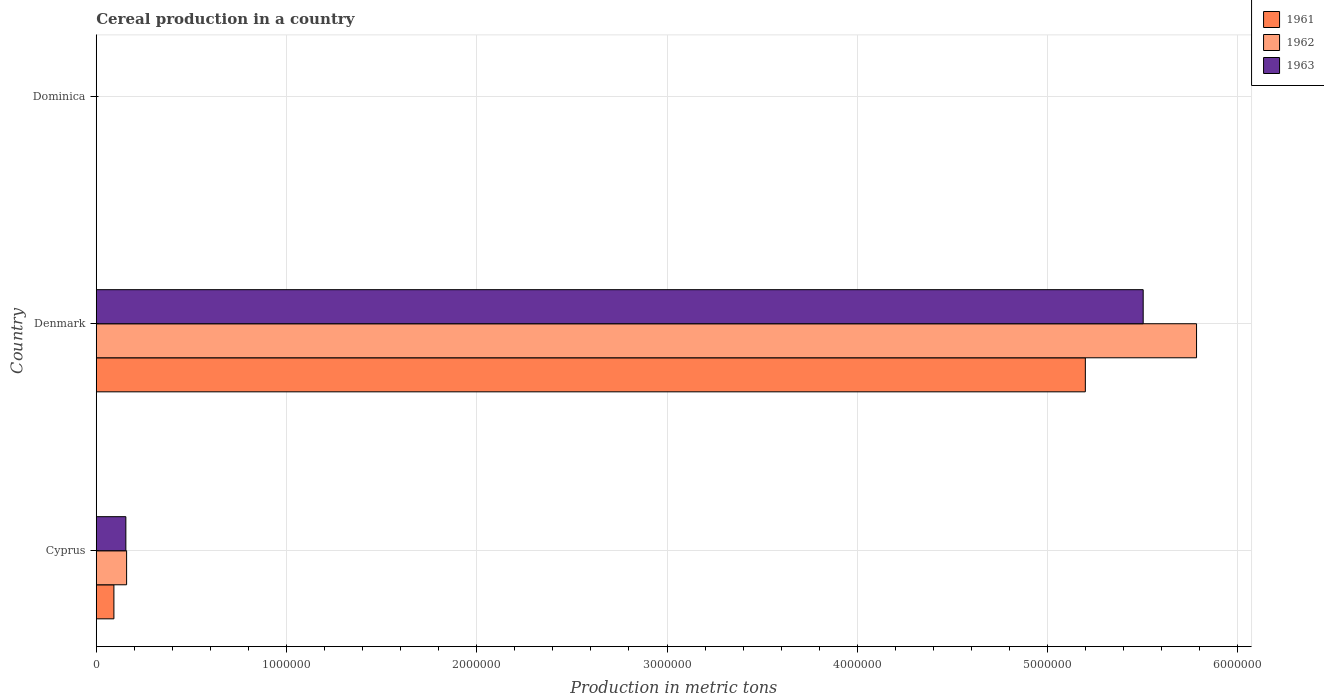Are the number of bars per tick equal to the number of legend labels?
Offer a very short reply. Yes. How many bars are there on the 2nd tick from the top?
Keep it short and to the point. 3. What is the label of the 3rd group of bars from the top?
Keep it short and to the point. Cyprus. What is the total cereal production in 1962 in Cyprus?
Your answer should be very brief. 1.60e+05. Across all countries, what is the maximum total cereal production in 1963?
Give a very brief answer. 5.50e+06. Across all countries, what is the minimum total cereal production in 1963?
Offer a terse response. 140. In which country was the total cereal production in 1961 minimum?
Offer a terse response. Dominica. What is the total total cereal production in 1963 in the graph?
Give a very brief answer. 5.66e+06. What is the difference between the total cereal production in 1961 in Denmark and that in Dominica?
Your answer should be very brief. 5.20e+06. What is the difference between the total cereal production in 1963 in Dominica and the total cereal production in 1961 in Cyprus?
Make the answer very short. -9.26e+04. What is the average total cereal production in 1962 per country?
Keep it short and to the point. 1.98e+06. What is the difference between the total cereal production in 1961 and total cereal production in 1962 in Dominica?
Offer a very short reply. 0. What is the ratio of the total cereal production in 1962 in Denmark to that in Dominica?
Offer a terse response. 4.45e+04. Is the difference between the total cereal production in 1961 in Cyprus and Dominica greater than the difference between the total cereal production in 1962 in Cyprus and Dominica?
Your answer should be very brief. No. What is the difference between the highest and the second highest total cereal production in 1963?
Provide a short and direct response. 5.35e+06. What is the difference between the highest and the lowest total cereal production in 1961?
Offer a very short reply. 5.20e+06. In how many countries, is the total cereal production in 1963 greater than the average total cereal production in 1963 taken over all countries?
Provide a succinct answer. 1. What does the 1st bar from the top in Denmark represents?
Keep it short and to the point. 1963. Is it the case that in every country, the sum of the total cereal production in 1963 and total cereal production in 1961 is greater than the total cereal production in 1962?
Your response must be concise. Yes. How many countries are there in the graph?
Your response must be concise. 3. What is the difference between two consecutive major ticks on the X-axis?
Offer a very short reply. 1.00e+06. Are the values on the major ticks of X-axis written in scientific E-notation?
Your response must be concise. No. Where does the legend appear in the graph?
Ensure brevity in your answer.  Top right. How many legend labels are there?
Your answer should be compact. 3. What is the title of the graph?
Provide a short and direct response. Cereal production in a country. What is the label or title of the X-axis?
Your answer should be very brief. Production in metric tons. What is the label or title of the Y-axis?
Your answer should be compact. Country. What is the Production in metric tons in 1961 in Cyprus?
Ensure brevity in your answer.  9.28e+04. What is the Production in metric tons in 1962 in Cyprus?
Make the answer very short. 1.60e+05. What is the Production in metric tons in 1963 in Cyprus?
Offer a very short reply. 1.56e+05. What is the Production in metric tons in 1961 in Denmark?
Ensure brevity in your answer.  5.20e+06. What is the Production in metric tons in 1962 in Denmark?
Offer a terse response. 5.78e+06. What is the Production in metric tons in 1963 in Denmark?
Keep it short and to the point. 5.50e+06. What is the Production in metric tons of 1961 in Dominica?
Keep it short and to the point. 130. What is the Production in metric tons in 1962 in Dominica?
Give a very brief answer. 130. What is the Production in metric tons of 1963 in Dominica?
Provide a succinct answer. 140. Across all countries, what is the maximum Production in metric tons of 1961?
Provide a succinct answer. 5.20e+06. Across all countries, what is the maximum Production in metric tons in 1962?
Your answer should be very brief. 5.78e+06. Across all countries, what is the maximum Production in metric tons of 1963?
Your answer should be compact. 5.50e+06. Across all countries, what is the minimum Production in metric tons in 1961?
Provide a succinct answer. 130. Across all countries, what is the minimum Production in metric tons of 1962?
Provide a short and direct response. 130. Across all countries, what is the minimum Production in metric tons in 1963?
Ensure brevity in your answer.  140. What is the total Production in metric tons of 1961 in the graph?
Keep it short and to the point. 5.29e+06. What is the total Production in metric tons in 1962 in the graph?
Your answer should be compact. 5.94e+06. What is the total Production in metric tons of 1963 in the graph?
Provide a succinct answer. 5.66e+06. What is the difference between the Production in metric tons of 1961 in Cyprus and that in Denmark?
Make the answer very short. -5.11e+06. What is the difference between the Production in metric tons in 1962 in Cyprus and that in Denmark?
Make the answer very short. -5.62e+06. What is the difference between the Production in metric tons of 1963 in Cyprus and that in Denmark?
Your answer should be very brief. -5.35e+06. What is the difference between the Production in metric tons in 1961 in Cyprus and that in Dominica?
Provide a short and direct response. 9.26e+04. What is the difference between the Production in metric tons of 1962 in Cyprus and that in Dominica?
Keep it short and to the point. 1.59e+05. What is the difference between the Production in metric tons in 1963 in Cyprus and that in Dominica?
Keep it short and to the point. 1.55e+05. What is the difference between the Production in metric tons in 1961 in Denmark and that in Dominica?
Your response must be concise. 5.20e+06. What is the difference between the Production in metric tons in 1962 in Denmark and that in Dominica?
Give a very brief answer. 5.78e+06. What is the difference between the Production in metric tons in 1963 in Denmark and that in Dominica?
Your response must be concise. 5.50e+06. What is the difference between the Production in metric tons of 1961 in Cyprus and the Production in metric tons of 1962 in Denmark?
Ensure brevity in your answer.  -5.69e+06. What is the difference between the Production in metric tons in 1961 in Cyprus and the Production in metric tons in 1963 in Denmark?
Your response must be concise. -5.41e+06. What is the difference between the Production in metric tons in 1962 in Cyprus and the Production in metric tons in 1963 in Denmark?
Make the answer very short. -5.34e+06. What is the difference between the Production in metric tons of 1961 in Cyprus and the Production in metric tons of 1962 in Dominica?
Ensure brevity in your answer.  9.26e+04. What is the difference between the Production in metric tons of 1961 in Cyprus and the Production in metric tons of 1963 in Dominica?
Keep it short and to the point. 9.26e+04. What is the difference between the Production in metric tons in 1962 in Cyprus and the Production in metric tons in 1963 in Dominica?
Your answer should be compact. 1.59e+05. What is the difference between the Production in metric tons in 1961 in Denmark and the Production in metric tons in 1962 in Dominica?
Provide a short and direct response. 5.20e+06. What is the difference between the Production in metric tons in 1961 in Denmark and the Production in metric tons in 1963 in Dominica?
Give a very brief answer. 5.20e+06. What is the difference between the Production in metric tons of 1962 in Denmark and the Production in metric tons of 1963 in Dominica?
Your answer should be very brief. 5.78e+06. What is the average Production in metric tons of 1961 per country?
Offer a terse response. 1.76e+06. What is the average Production in metric tons of 1962 per country?
Your answer should be compact. 1.98e+06. What is the average Production in metric tons of 1963 per country?
Keep it short and to the point. 1.89e+06. What is the difference between the Production in metric tons in 1961 and Production in metric tons in 1962 in Cyprus?
Provide a succinct answer. -6.68e+04. What is the difference between the Production in metric tons in 1961 and Production in metric tons in 1963 in Cyprus?
Ensure brevity in your answer.  -6.28e+04. What is the difference between the Production in metric tons in 1962 and Production in metric tons in 1963 in Cyprus?
Ensure brevity in your answer.  3950. What is the difference between the Production in metric tons in 1961 and Production in metric tons in 1962 in Denmark?
Offer a terse response. -5.85e+05. What is the difference between the Production in metric tons in 1961 and Production in metric tons in 1963 in Denmark?
Keep it short and to the point. -3.04e+05. What is the difference between the Production in metric tons of 1962 and Production in metric tons of 1963 in Denmark?
Offer a terse response. 2.80e+05. What is the difference between the Production in metric tons in 1961 and Production in metric tons in 1962 in Dominica?
Make the answer very short. 0. What is the difference between the Production in metric tons in 1961 and Production in metric tons in 1963 in Dominica?
Your answer should be compact. -10. What is the ratio of the Production in metric tons in 1961 in Cyprus to that in Denmark?
Ensure brevity in your answer.  0.02. What is the ratio of the Production in metric tons of 1962 in Cyprus to that in Denmark?
Offer a very short reply. 0.03. What is the ratio of the Production in metric tons of 1963 in Cyprus to that in Denmark?
Your response must be concise. 0.03. What is the ratio of the Production in metric tons in 1961 in Cyprus to that in Dominica?
Ensure brevity in your answer.  713.55. What is the ratio of the Production in metric tons of 1962 in Cyprus to that in Dominica?
Make the answer very short. 1227.02. What is the ratio of the Production in metric tons in 1963 in Cyprus to that in Dominica?
Offer a very short reply. 1111.16. What is the ratio of the Production in metric tons of 1961 in Denmark to that in Dominica?
Offer a very short reply. 4.00e+04. What is the ratio of the Production in metric tons in 1962 in Denmark to that in Dominica?
Make the answer very short. 4.45e+04. What is the ratio of the Production in metric tons in 1963 in Denmark to that in Dominica?
Provide a short and direct response. 3.93e+04. What is the difference between the highest and the second highest Production in metric tons in 1961?
Your response must be concise. 5.11e+06. What is the difference between the highest and the second highest Production in metric tons of 1962?
Your response must be concise. 5.62e+06. What is the difference between the highest and the second highest Production in metric tons in 1963?
Offer a very short reply. 5.35e+06. What is the difference between the highest and the lowest Production in metric tons in 1961?
Offer a very short reply. 5.20e+06. What is the difference between the highest and the lowest Production in metric tons of 1962?
Give a very brief answer. 5.78e+06. What is the difference between the highest and the lowest Production in metric tons in 1963?
Your response must be concise. 5.50e+06. 